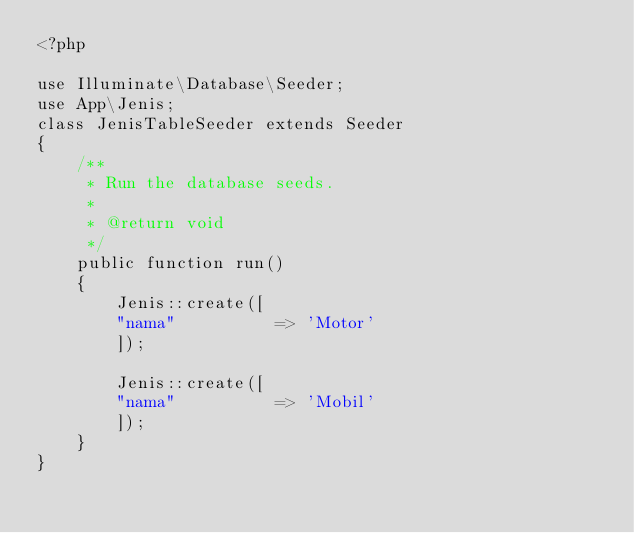Convert code to text. <code><loc_0><loc_0><loc_500><loc_500><_PHP_><?php

use Illuminate\Database\Seeder;
use App\Jenis;
class JenisTableSeeder extends Seeder
{
    /**
     * Run the database seeds.
     *
     * @return void
     */
    public function run()
    {
        Jenis::create([
        "nama"			=> 'Motor'
        ]);

        Jenis::create([
        "nama"			=> 'Mobil'
        ]);
    }
}
</code> 